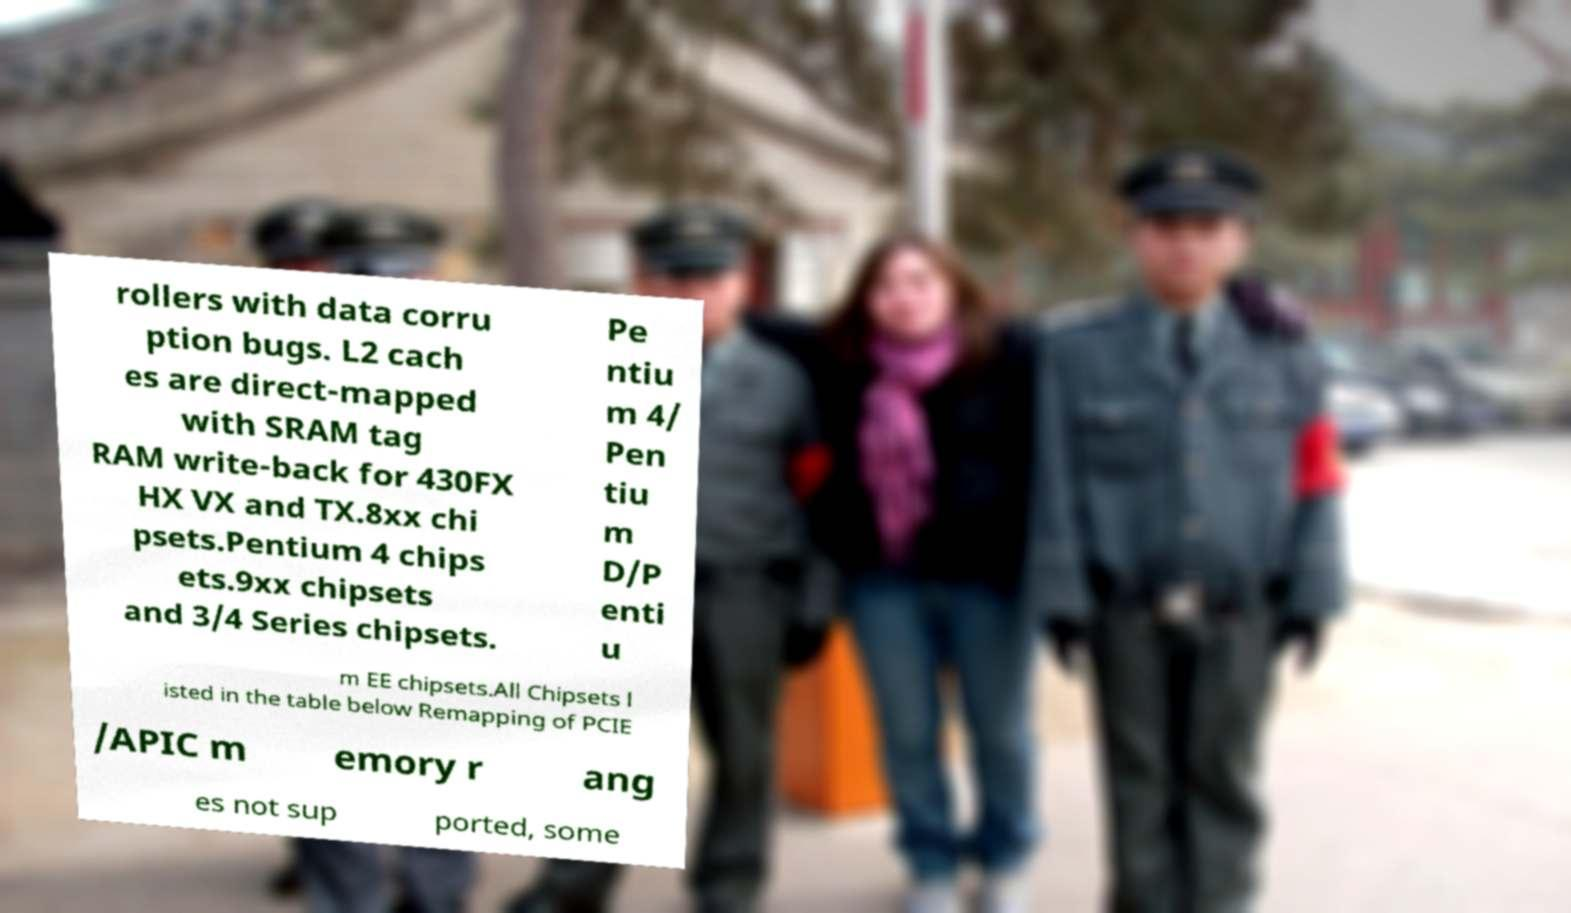I need the written content from this picture converted into text. Can you do that? rollers with data corru ption bugs. L2 cach es are direct-mapped with SRAM tag RAM write-back for 430FX HX VX and TX.8xx chi psets.Pentium 4 chips ets.9xx chipsets and 3/4 Series chipsets. Pe ntiu m 4/ Pen tiu m D/P enti u m EE chipsets.All Chipsets l isted in the table below Remapping of PCIE /APIC m emory r ang es not sup ported, some 